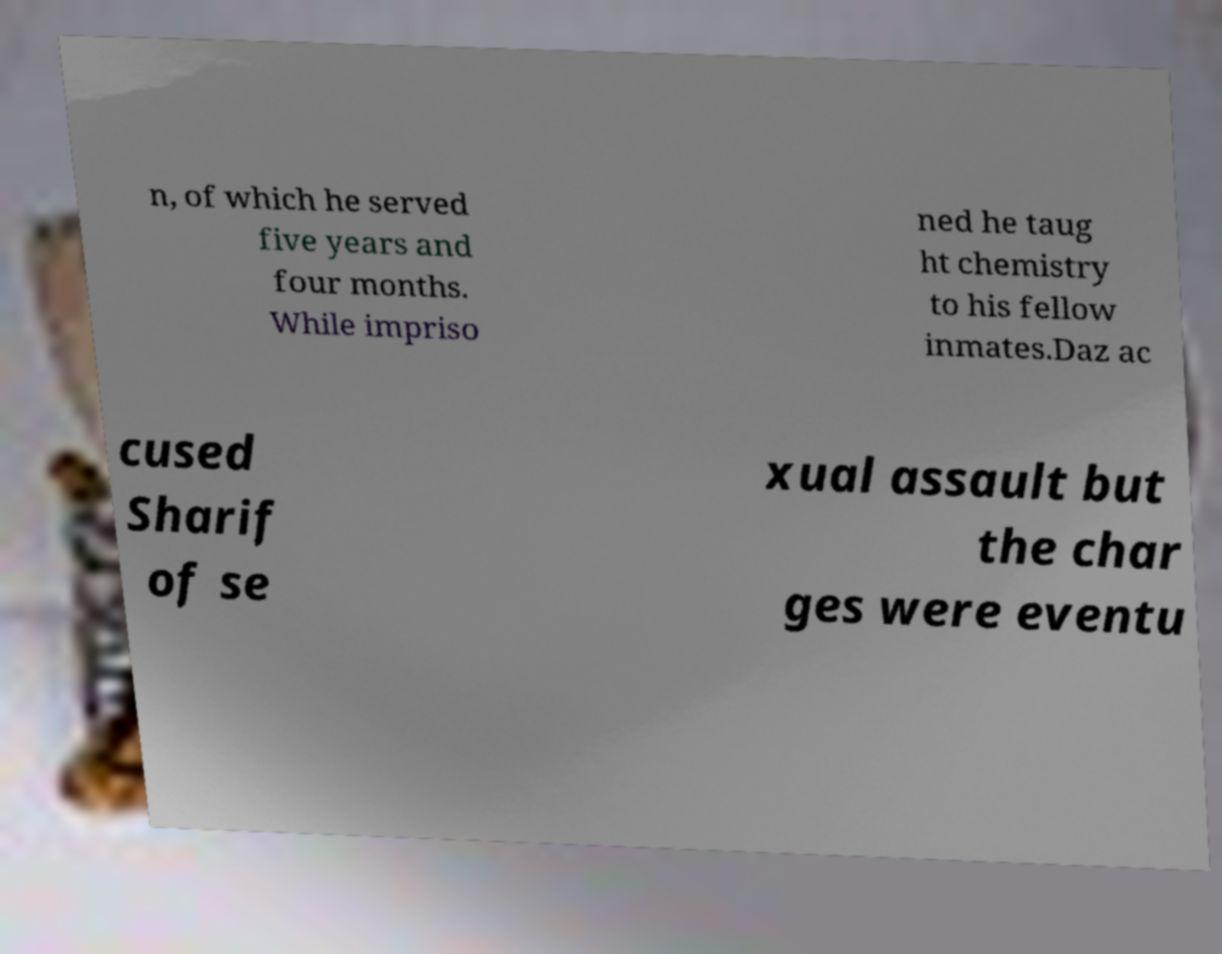Could you extract and type out the text from this image? n, of which he served five years and four months. While impriso ned he taug ht chemistry to his fellow inmates.Daz ac cused Sharif of se xual assault but the char ges were eventu 